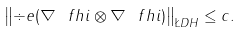<formula> <loc_0><loc_0><loc_500><loc_500>\left \| \div e ( \nabla \ f h i \otimes \nabla \ f h i ) \right \| _ { \L D H } \leq c .</formula> 